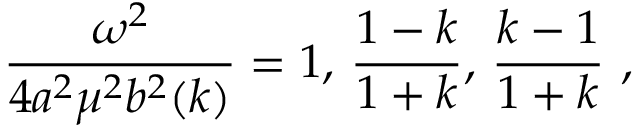<formula> <loc_0><loc_0><loc_500><loc_500>{ \frac { \omega ^ { 2 } } { 4 a ^ { 2 } \mu ^ { 2 } b ^ { 2 } ( k ) } } = 1 , \, { \frac { 1 - k } { 1 + k } } , \, { \frac { k - 1 } { 1 + k } } ,</formula> 